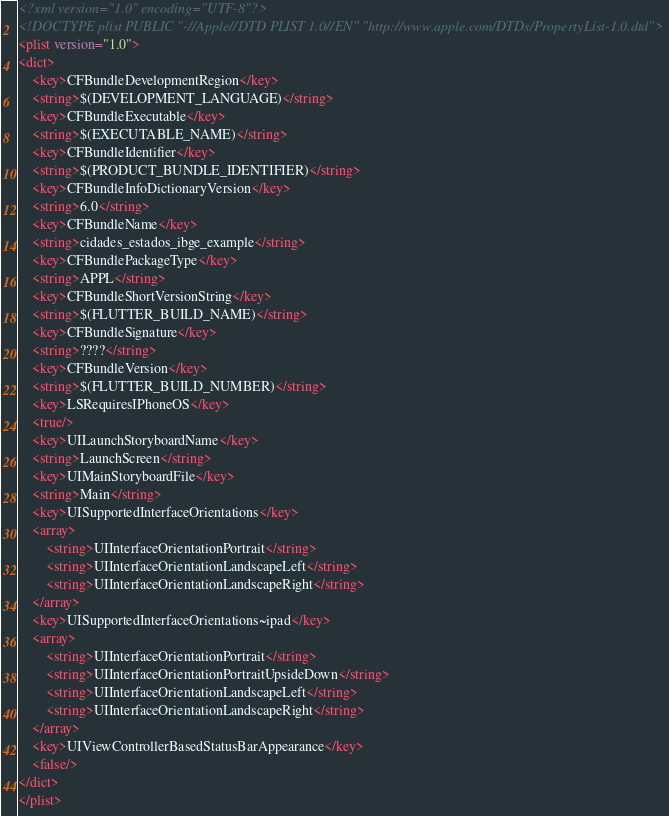<code> <loc_0><loc_0><loc_500><loc_500><_XML_><?xml version="1.0" encoding="UTF-8"?>
<!DOCTYPE plist PUBLIC "-//Apple//DTD PLIST 1.0//EN" "http://www.apple.com/DTDs/PropertyList-1.0.dtd">
<plist version="1.0">
<dict>
	<key>CFBundleDevelopmentRegion</key>
	<string>$(DEVELOPMENT_LANGUAGE)</string>
	<key>CFBundleExecutable</key>
	<string>$(EXECUTABLE_NAME)</string>
	<key>CFBundleIdentifier</key>
	<string>$(PRODUCT_BUNDLE_IDENTIFIER)</string>
	<key>CFBundleInfoDictionaryVersion</key>
	<string>6.0</string>
	<key>CFBundleName</key>
	<string>cidades_estados_ibge_example</string>
	<key>CFBundlePackageType</key>
	<string>APPL</string>
	<key>CFBundleShortVersionString</key>
	<string>$(FLUTTER_BUILD_NAME)</string>
	<key>CFBundleSignature</key>
	<string>????</string>
	<key>CFBundleVersion</key>
	<string>$(FLUTTER_BUILD_NUMBER)</string>
	<key>LSRequiresIPhoneOS</key>
	<true/>
	<key>UILaunchStoryboardName</key>
	<string>LaunchScreen</string>
	<key>UIMainStoryboardFile</key>
	<string>Main</string>
	<key>UISupportedInterfaceOrientations</key>
	<array>
		<string>UIInterfaceOrientationPortrait</string>
		<string>UIInterfaceOrientationLandscapeLeft</string>
		<string>UIInterfaceOrientationLandscapeRight</string>
	</array>
	<key>UISupportedInterfaceOrientations~ipad</key>
	<array>
		<string>UIInterfaceOrientationPortrait</string>
		<string>UIInterfaceOrientationPortraitUpsideDown</string>
		<string>UIInterfaceOrientationLandscapeLeft</string>
		<string>UIInterfaceOrientationLandscapeRight</string>
	</array>
	<key>UIViewControllerBasedStatusBarAppearance</key>
	<false/>
</dict>
</plist>
</code> 